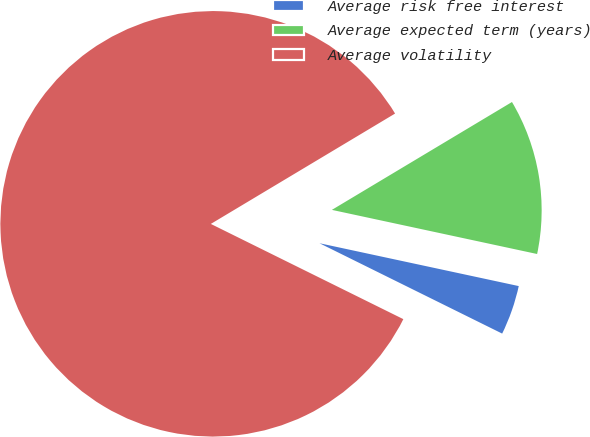Convert chart. <chart><loc_0><loc_0><loc_500><loc_500><pie_chart><fcel>Average risk free interest<fcel>Average expected term (years)<fcel>Average volatility<nl><fcel>3.94%<fcel>11.96%<fcel>84.1%<nl></chart> 